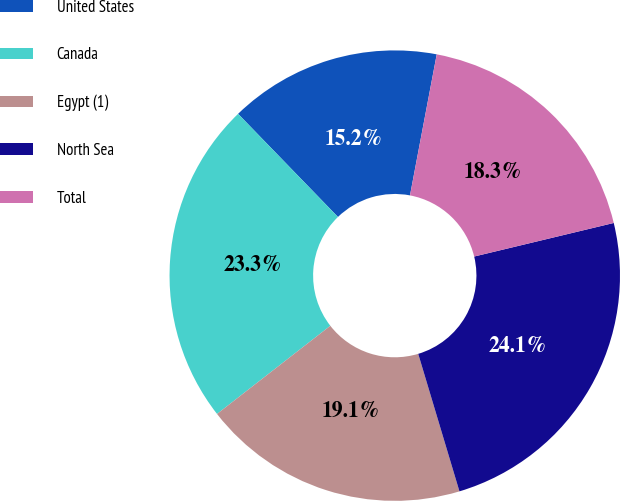Convert chart. <chart><loc_0><loc_0><loc_500><loc_500><pie_chart><fcel>United States<fcel>Canada<fcel>Egypt (1)<fcel>North Sea<fcel>Total<nl><fcel>15.23%<fcel>23.28%<fcel>19.11%<fcel>24.12%<fcel>18.26%<nl></chart> 